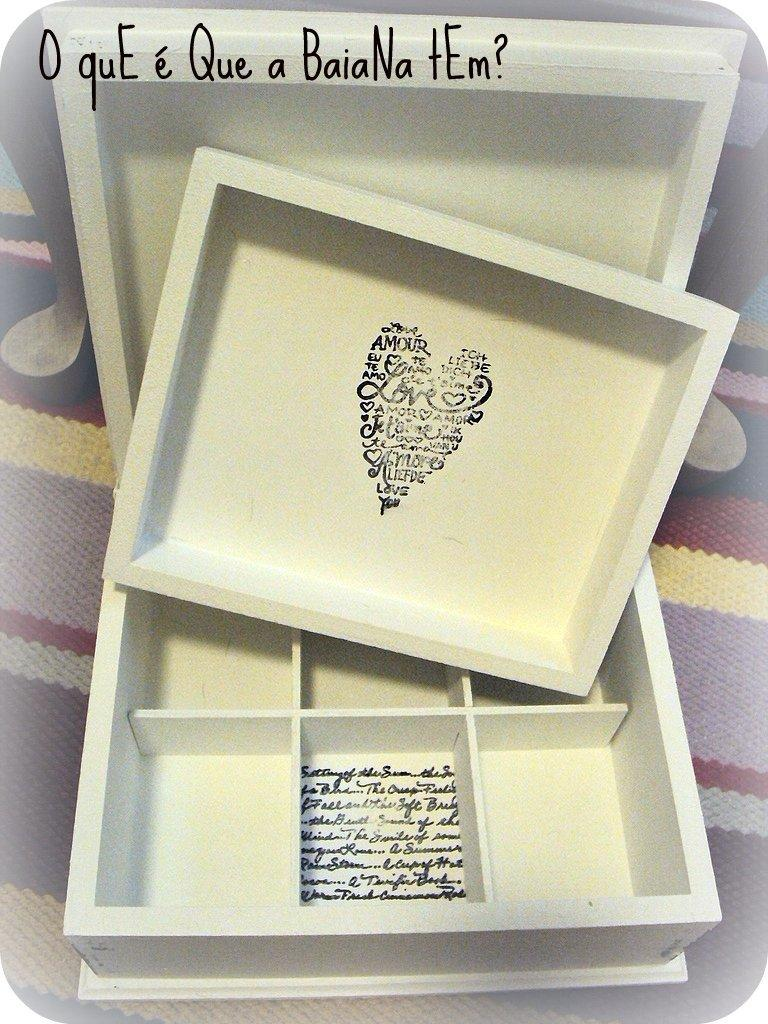Provide a one-sentence caption for the provided image. A shape of a heart is filled with letters and has "Love" in the center of it. 